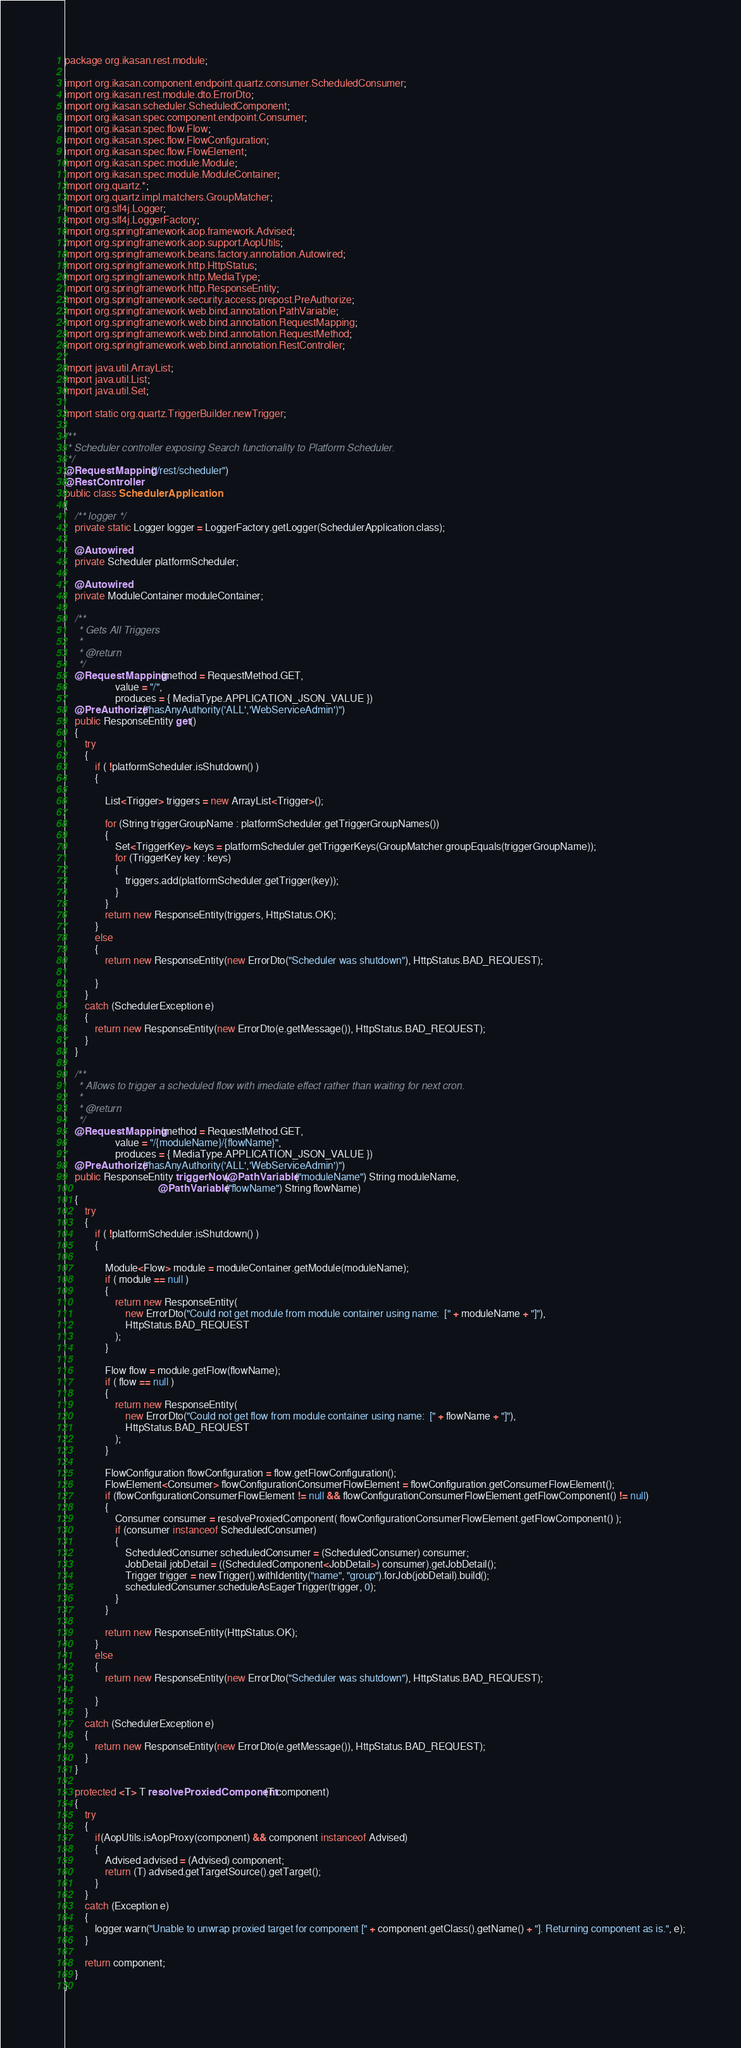<code> <loc_0><loc_0><loc_500><loc_500><_Java_>package org.ikasan.rest.module;

import org.ikasan.component.endpoint.quartz.consumer.ScheduledConsumer;
import org.ikasan.rest.module.dto.ErrorDto;
import org.ikasan.scheduler.ScheduledComponent;
import org.ikasan.spec.component.endpoint.Consumer;
import org.ikasan.spec.flow.Flow;
import org.ikasan.spec.flow.FlowConfiguration;
import org.ikasan.spec.flow.FlowElement;
import org.ikasan.spec.module.Module;
import org.ikasan.spec.module.ModuleContainer;
import org.quartz.*;
import org.quartz.impl.matchers.GroupMatcher;
import org.slf4j.Logger;
import org.slf4j.LoggerFactory;
import org.springframework.aop.framework.Advised;
import org.springframework.aop.support.AopUtils;
import org.springframework.beans.factory.annotation.Autowired;
import org.springframework.http.HttpStatus;
import org.springframework.http.MediaType;
import org.springframework.http.ResponseEntity;
import org.springframework.security.access.prepost.PreAuthorize;
import org.springframework.web.bind.annotation.PathVariable;
import org.springframework.web.bind.annotation.RequestMapping;
import org.springframework.web.bind.annotation.RequestMethod;
import org.springframework.web.bind.annotation.RestController;

import java.util.ArrayList;
import java.util.List;
import java.util.Set;

import static org.quartz.TriggerBuilder.newTrigger;

/**
 * Scheduler controller exposing Search functionality to Platform Scheduler.
 */
@RequestMapping("/rest/scheduler")
@RestController
public class SchedulerApplication
{
    /** logger */
    private static Logger logger = LoggerFactory.getLogger(SchedulerApplication.class);

    @Autowired
    private Scheduler platformScheduler;

    @Autowired
    private ModuleContainer moduleContainer;

    /**
     * Gets All Triggers
     *
     * @return
     */
    @RequestMapping(method = RequestMethod.GET,
                    value = "/",
                    produces = { MediaType.APPLICATION_JSON_VALUE })
    @PreAuthorize("hasAnyAuthority('ALL','WebServiceAdmin')")
    public ResponseEntity get()
    {
        try
        {
            if ( !platformScheduler.isShutdown() )
            {

                List<Trigger> triggers = new ArrayList<Trigger>();

                for (String triggerGroupName : platformScheduler.getTriggerGroupNames())
                {
                    Set<TriggerKey> keys = platformScheduler.getTriggerKeys(GroupMatcher.groupEquals(triggerGroupName));
                    for (TriggerKey key : keys)
                    {
                        triggers.add(platformScheduler.getTrigger(key));
                    }
                }
                return new ResponseEntity(triggers, HttpStatus.OK);
            }
            else
            {
                return new ResponseEntity(new ErrorDto("Scheduler was shutdown"), HttpStatus.BAD_REQUEST);

            }
        }
        catch (SchedulerException e)
        {
            return new ResponseEntity(new ErrorDto(e.getMessage()), HttpStatus.BAD_REQUEST);
        }
    }

    /**
     * Allows to trigger a scheduled flow with imediate effect rather than waiting for next cron.
     *
     * @return
     */
    @RequestMapping(method = RequestMethod.GET,
                    value = "/{moduleName}/{flowName}",
                    produces = { MediaType.APPLICATION_JSON_VALUE })
    @PreAuthorize("hasAnyAuthority('ALL','WebServiceAdmin')")
    public ResponseEntity triggerNow(@PathVariable("moduleName") String moduleName,
                                     @PathVariable("flowName") String flowName)
    {
        try
        {
            if ( !platformScheduler.isShutdown() )
            {

                Module<Flow> module = moduleContainer.getModule(moduleName);
                if ( module == null )
                {
                    return new ResponseEntity(
                        new ErrorDto("Could not get module from module container using name:  [" + moduleName + "]"),
                        HttpStatus.BAD_REQUEST
                    );
                }

                Flow flow = module.getFlow(flowName);
                if ( flow == null )
                {
                    return new ResponseEntity(
                        new ErrorDto("Could not get flow from module container using name:  [" + flowName + "]"),
                        HttpStatus.BAD_REQUEST
                    );
                }

                FlowConfiguration flowConfiguration = flow.getFlowConfiguration();
                FlowElement<Consumer> flowConfigurationConsumerFlowElement = flowConfiguration.getConsumerFlowElement();
                if (flowConfigurationConsumerFlowElement != null && flowConfigurationConsumerFlowElement.getFlowComponent() != null)
                {
                    Consumer consumer = resolveProxiedComponent( flowConfigurationConsumerFlowElement.getFlowComponent() );
                    if (consumer instanceof ScheduledConsumer)
                    {
                        ScheduledConsumer scheduledConsumer = (ScheduledConsumer) consumer;
                        JobDetail jobDetail = ((ScheduledComponent<JobDetail>) consumer).getJobDetail();
                        Trigger trigger = newTrigger().withIdentity("name", "group").forJob(jobDetail).build();
                        scheduledConsumer.scheduleAsEagerTrigger(trigger, 0);
                    }
                }

                return new ResponseEntity(HttpStatus.OK);
            }
            else
            {
                return new ResponseEntity(new ErrorDto("Scheduler was shutdown"), HttpStatus.BAD_REQUEST);

            }
        }
        catch (SchedulerException e)
        {
            return new ResponseEntity(new ErrorDto(e.getMessage()), HttpStatus.BAD_REQUEST);
        }
    }

    protected <T> T resolveProxiedComponent(T component)
    {
        try
        {
            if(AopUtils.isAopProxy(component) && component instanceof Advised)
            {
                Advised advised = (Advised) component;
                return (T) advised.getTargetSource().getTarget();
            }
        }
        catch (Exception e)
        {
            logger.warn("Unable to unwrap proxied target for component [" + component.getClass().getName() + "]. Returning component as is.", e);
        }

        return component;
    }
}
</code> 